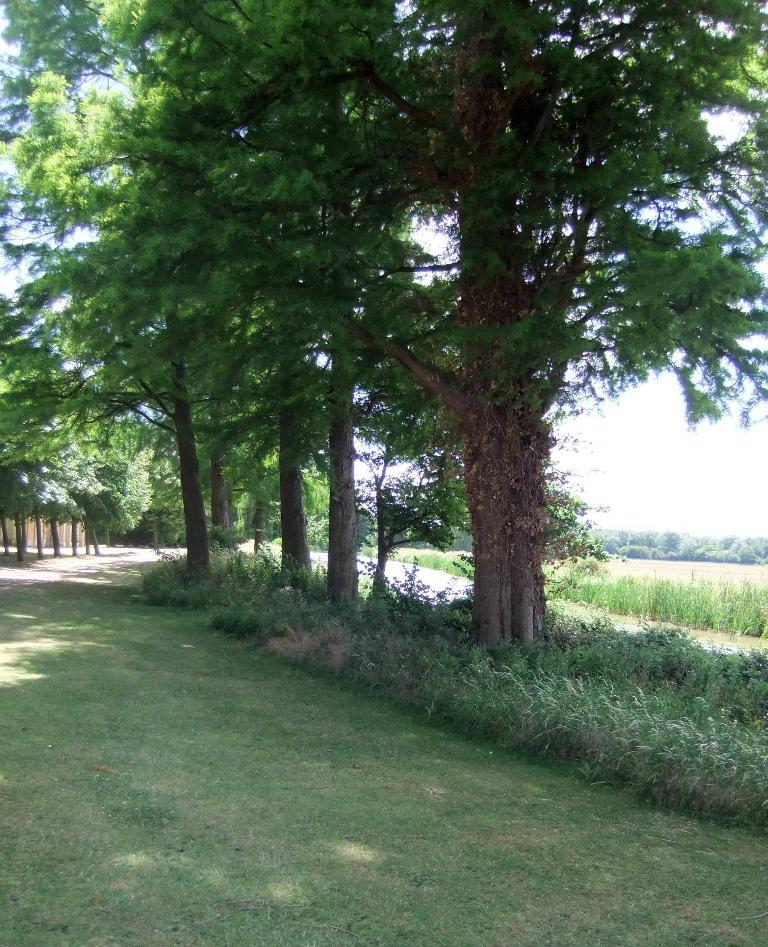What type of vegetation is present on the ground in the front of the image? There is grass on the ground in the front of the image. What can be seen in the background of the image? There are trees in the background of the image. What other types of vegetation are present in the image? There are plants in the image. Where is the coal mine located in the image? There is no coal mine present in the image. What type of soap can be seen being used to clean the plants in the image? There is no soap or cleaning activity depicted in the image; it features grass, trees, and plants. 